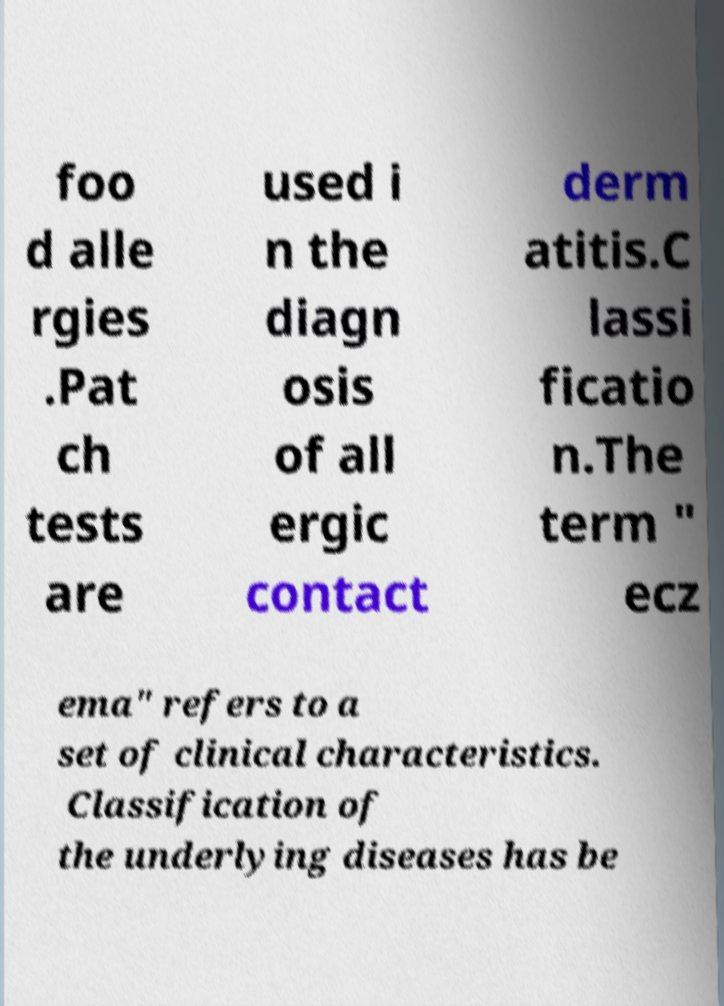Please read and relay the text visible in this image. What does it say? foo d alle rgies .Pat ch tests are used i n the diagn osis of all ergic contact derm atitis.C lassi ficatio n.The term " ecz ema" refers to a set of clinical characteristics. Classification of the underlying diseases has be 